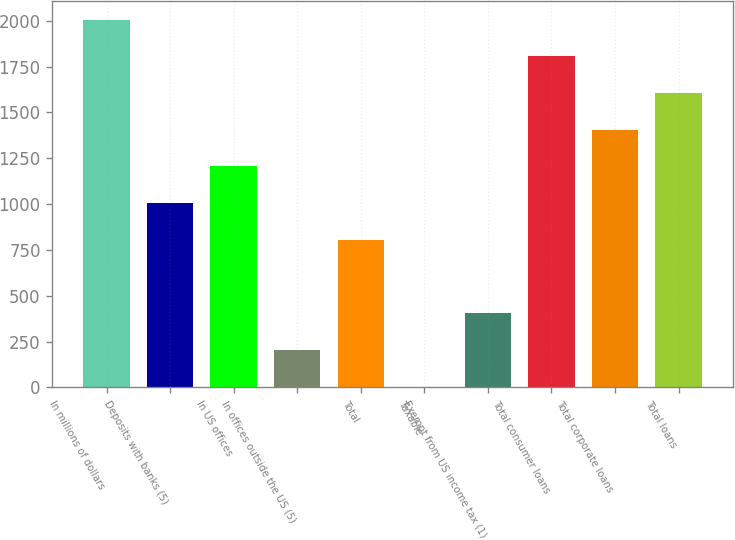Convert chart. <chart><loc_0><loc_0><loc_500><loc_500><bar_chart><fcel>In millions of dollars<fcel>Deposits with banks (5)<fcel>In US offices<fcel>In offices outside the US (5)<fcel>Total<fcel>Taxable<fcel>Exempt from US income tax (1)<fcel>Total consumer loans<fcel>Total corporate loans<fcel>Total loans<nl><fcel>2007.01<fcel>1006.01<fcel>1206.21<fcel>205.21<fcel>805.81<fcel>5.01<fcel>405.41<fcel>1806.81<fcel>1406.41<fcel>1606.61<nl></chart> 